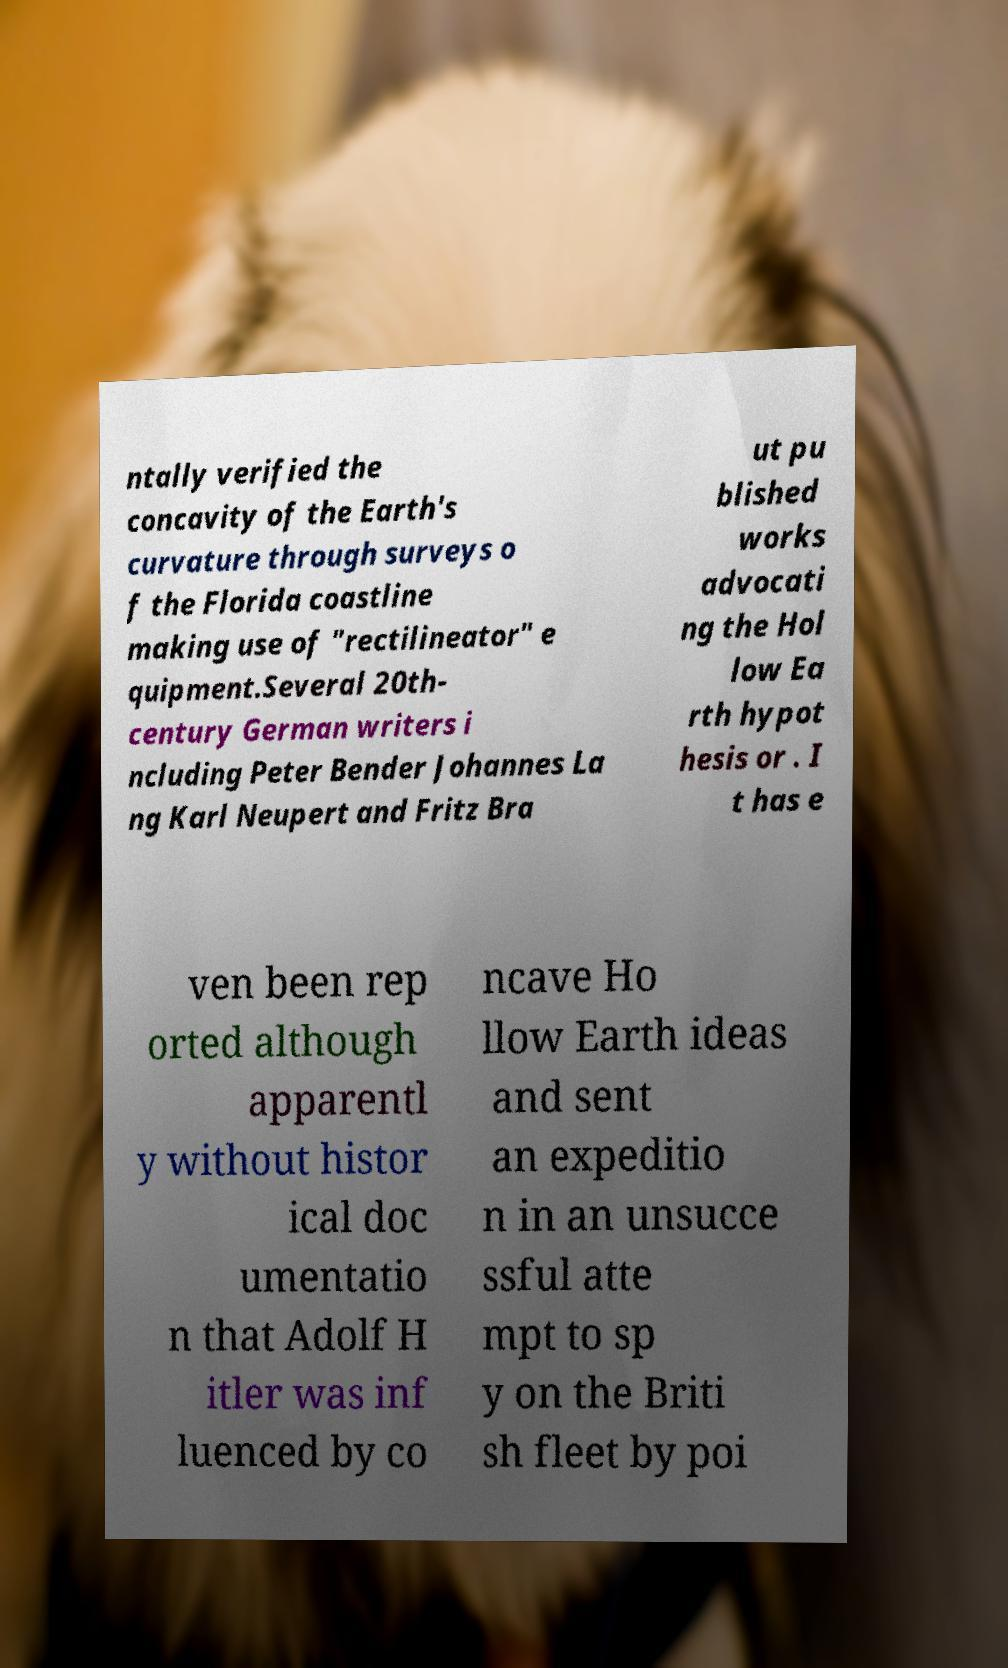For documentation purposes, I need the text within this image transcribed. Could you provide that? ntally verified the concavity of the Earth's curvature through surveys o f the Florida coastline making use of "rectilineator" e quipment.Several 20th- century German writers i ncluding Peter Bender Johannes La ng Karl Neupert and Fritz Bra ut pu blished works advocati ng the Hol low Ea rth hypot hesis or . I t has e ven been rep orted although apparentl y without histor ical doc umentatio n that Adolf H itler was inf luenced by co ncave Ho llow Earth ideas and sent an expeditio n in an unsucce ssful atte mpt to sp y on the Briti sh fleet by poi 